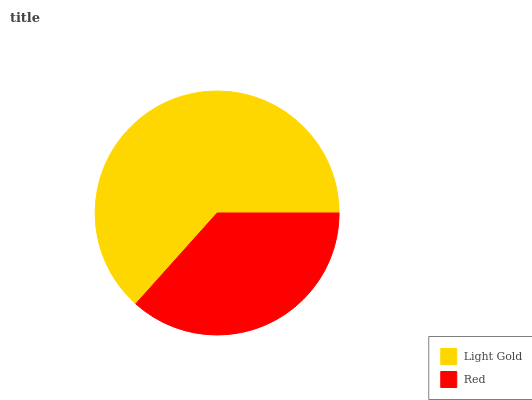Is Red the minimum?
Answer yes or no. Yes. Is Light Gold the maximum?
Answer yes or no. Yes. Is Red the maximum?
Answer yes or no. No. Is Light Gold greater than Red?
Answer yes or no. Yes. Is Red less than Light Gold?
Answer yes or no. Yes. Is Red greater than Light Gold?
Answer yes or no. No. Is Light Gold less than Red?
Answer yes or no. No. Is Light Gold the high median?
Answer yes or no. Yes. Is Red the low median?
Answer yes or no. Yes. Is Red the high median?
Answer yes or no. No. Is Light Gold the low median?
Answer yes or no. No. 